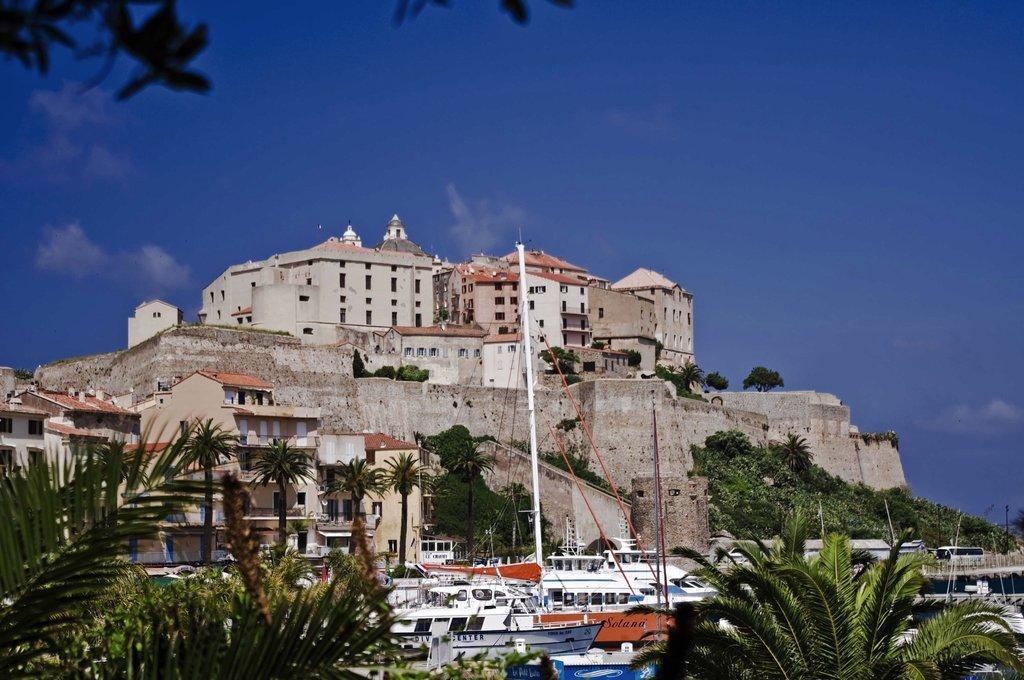How would you summarize this image in a sentence or two? This image consists of a building. In the front, we can see a wall. At the bottom, there are boats and trees. At the top, there is sky. 